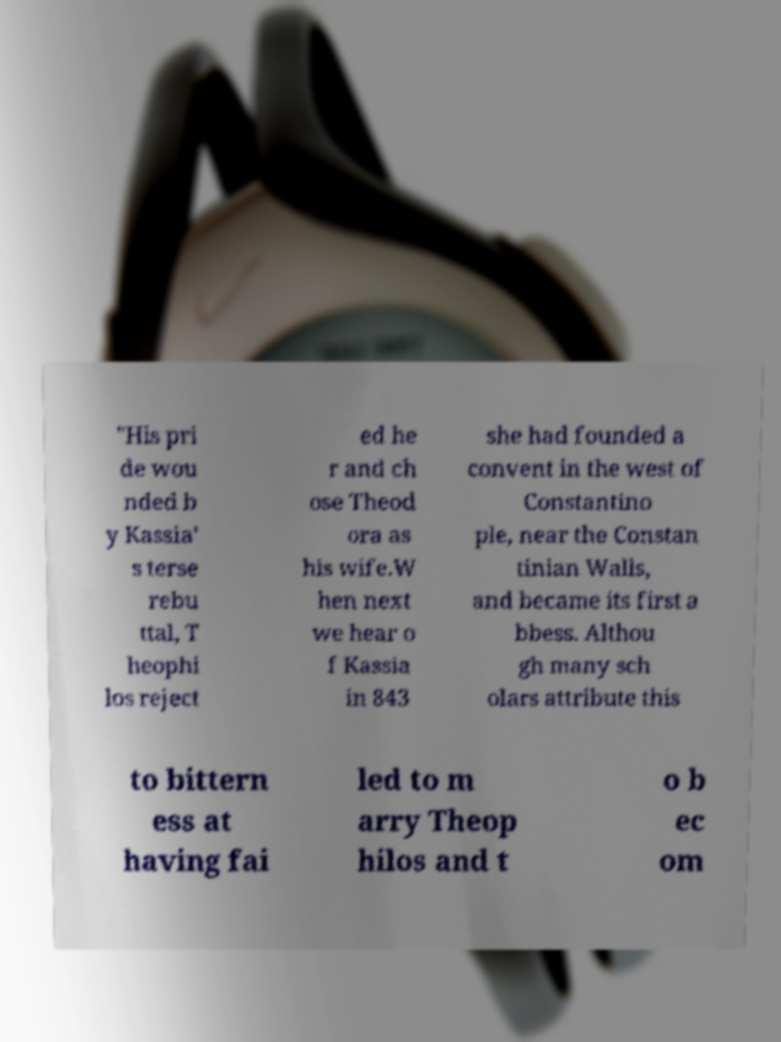What messages or text are displayed in this image? I need them in a readable, typed format. "His pri de wou nded b y Kassia' s terse rebu ttal, T heophi los reject ed he r and ch ose Theod ora as his wife.W hen next we hear o f Kassia in 843 she had founded a convent in the west of Constantino ple, near the Constan tinian Walls, and became its first a bbess. Althou gh many sch olars attribute this to bittern ess at having fai led to m arry Theop hilos and t o b ec om 